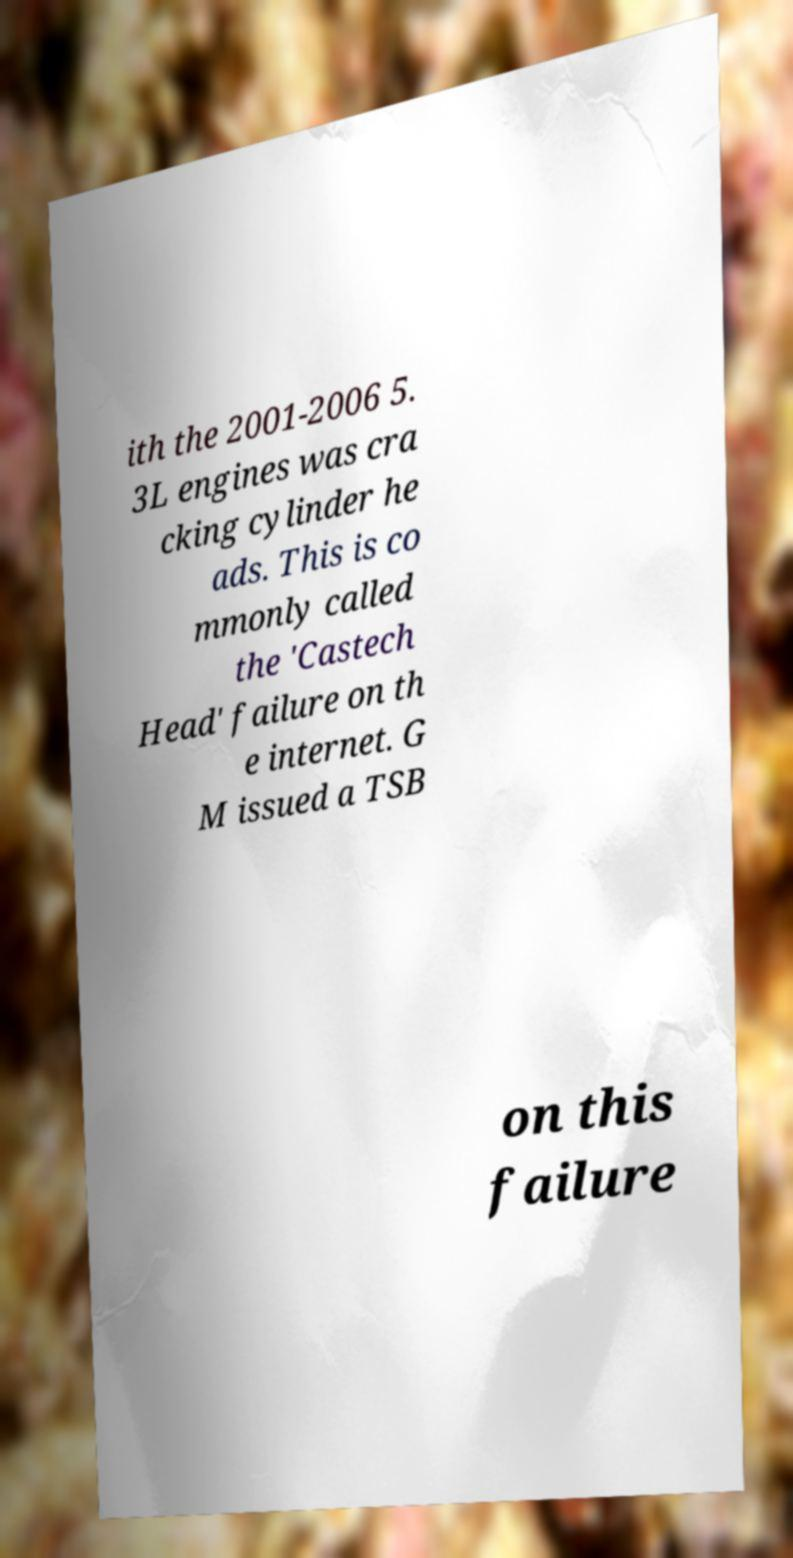Can you accurately transcribe the text from the provided image for me? ith the 2001-2006 5. 3L engines was cra cking cylinder he ads. This is co mmonly called the 'Castech Head' failure on th e internet. G M issued a TSB on this failure 